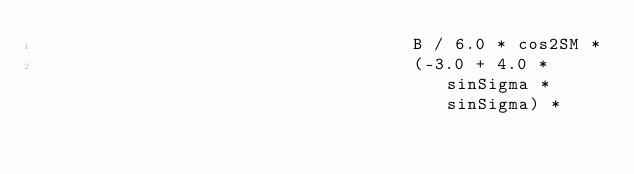<code> <loc_0><loc_0><loc_500><loc_500><_Kotlin_>                                    B / 6.0 * cos2SM *
                                    (-3.0 + 4.0 * sinSigma * sinSigma) *</code> 